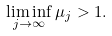<formula> <loc_0><loc_0><loc_500><loc_500>\liminf _ { j \rightarrow \infty } \mu _ { j } > 1 .</formula> 